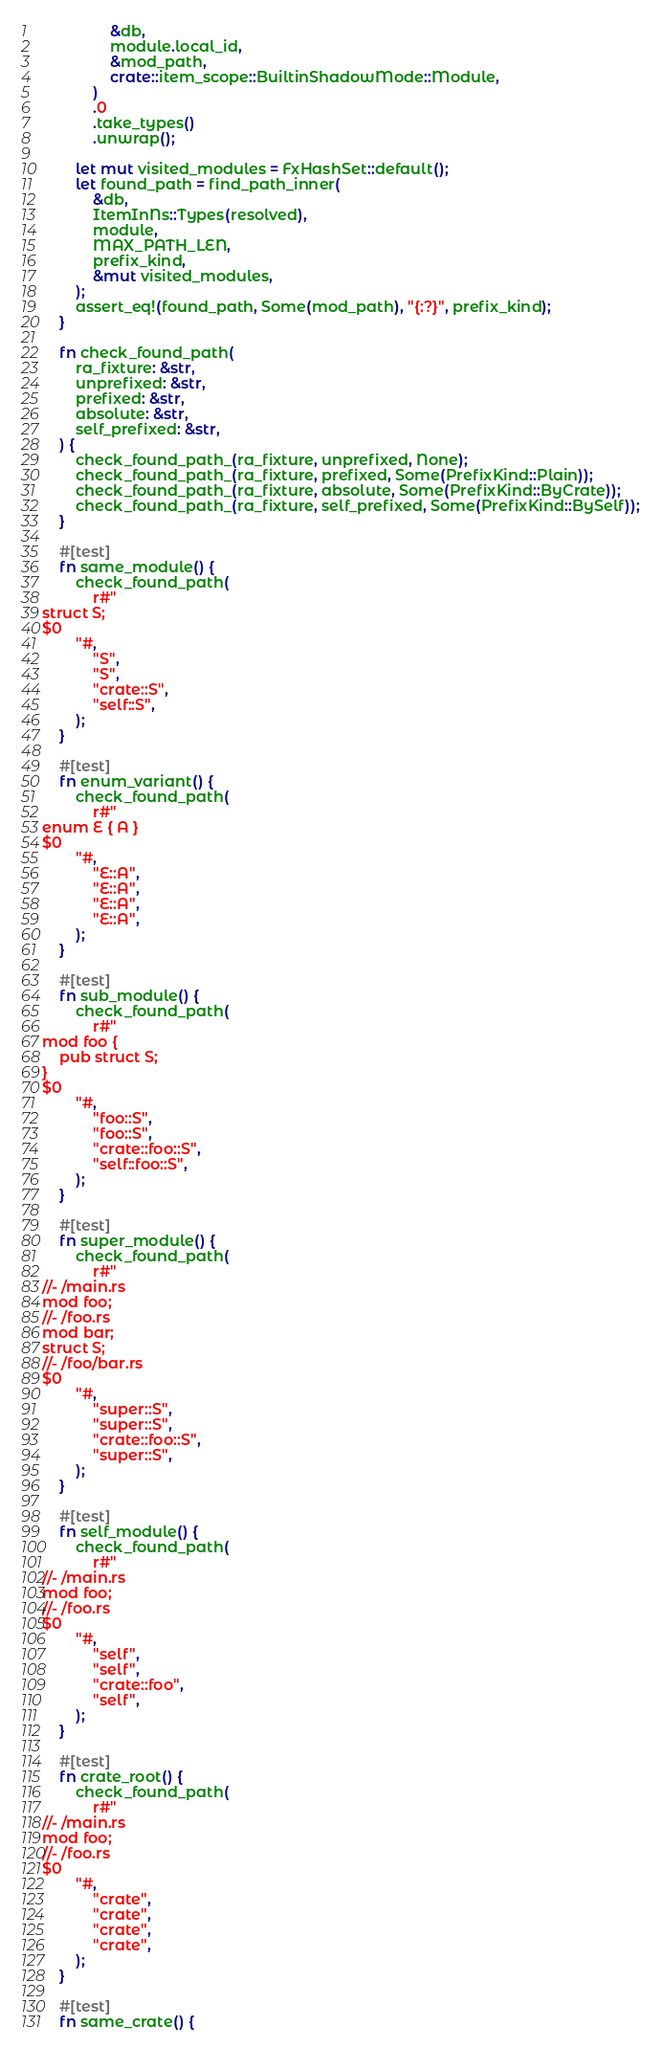<code> <loc_0><loc_0><loc_500><loc_500><_Rust_>                &db,
                module.local_id,
                &mod_path,
                crate::item_scope::BuiltinShadowMode::Module,
            )
            .0
            .take_types()
            .unwrap();

        let mut visited_modules = FxHashSet::default();
        let found_path = find_path_inner(
            &db,
            ItemInNs::Types(resolved),
            module,
            MAX_PATH_LEN,
            prefix_kind,
            &mut visited_modules,
        );
        assert_eq!(found_path, Some(mod_path), "{:?}", prefix_kind);
    }

    fn check_found_path(
        ra_fixture: &str,
        unprefixed: &str,
        prefixed: &str,
        absolute: &str,
        self_prefixed: &str,
    ) {
        check_found_path_(ra_fixture, unprefixed, None);
        check_found_path_(ra_fixture, prefixed, Some(PrefixKind::Plain));
        check_found_path_(ra_fixture, absolute, Some(PrefixKind::ByCrate));
        check_found_path_(ra_fixture, self_prefixed, Some(PrefixKind::BySelf));
    }

    #[test]
    fn same_module() {
        check_found_path(
            r#"
struct S;
$0
        "#,
            "S",
            "S",
            "crate::S",
            "self::S",
        );
    }

    #[test]
    fn enum_variant() {
        check_found_path(
            r#"
enum E { A }
$0
        "#,
            "E::A",
            "E::A",
            "E::A",
            "E::A",
        );
    }

    #[test]
    fn sub_module() {
        check_found_path(
            r#"
mod foo {
    pub struct S;
}
$0
        "#,
            "foo::S",
            "foo::S",
            "crate::foo::S",
            "self::foo::S",
        );
    }

    #[test]
    fn super_module() {
        check_found_path(
            r#"
//- /main.rs
mod foo;
//- /foo.rs
mod bar;
struct S;
//- /foo/bar.rs
$0
        "#,
            "super::S",
            "super::S",
            "crate::foo::S",
            "super::S",
        );
    }

    #[test]
    fn self_module() {
        check_found_path(
            r#"
//- /main.rs
mod foo;
//- /foo.rs
$0
        "#,
            "self",
            "self",
            "crate::foo",
            "self",
        );
    }

    #[test]
    fn crate_root() {
        check_found_path(
            r#"
//- /main.rs
mod foo;
//- /foo.rs
$0
        "#,
            "crate",
            "crate",
            "crate",
            "crate",
        );
    }

    #[test]
    fn same_crate() {</code> 